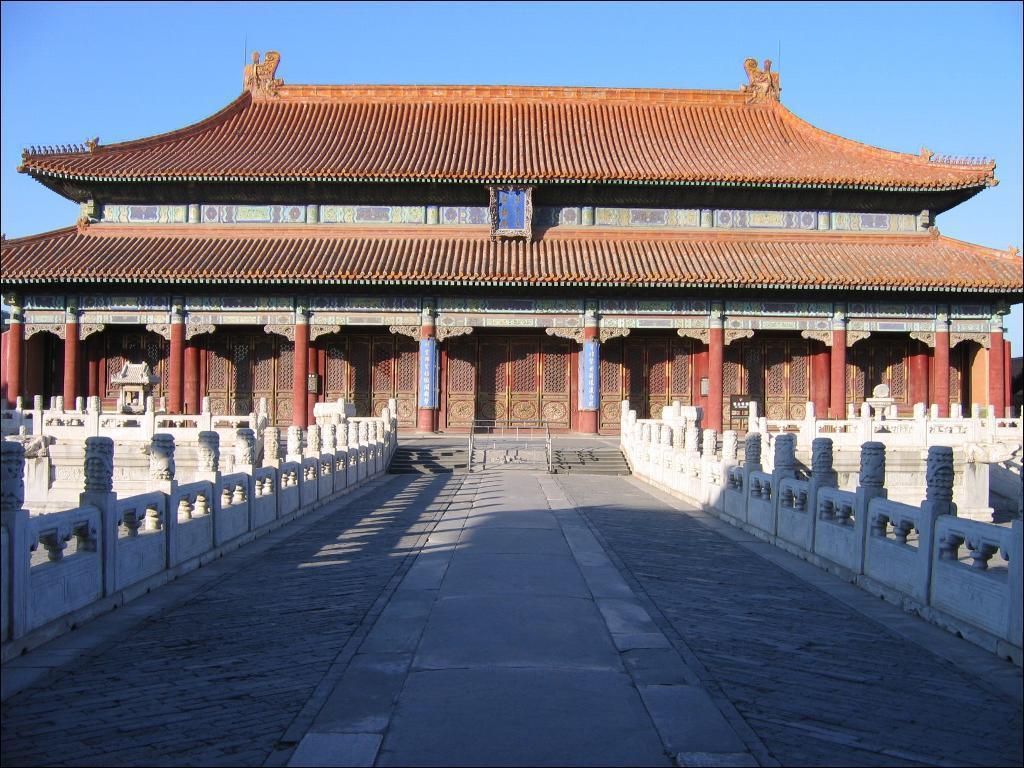Please provide a concise description of this image. This picture consists of a house and in front of house there is a bridge at the top there is the sky visible. 